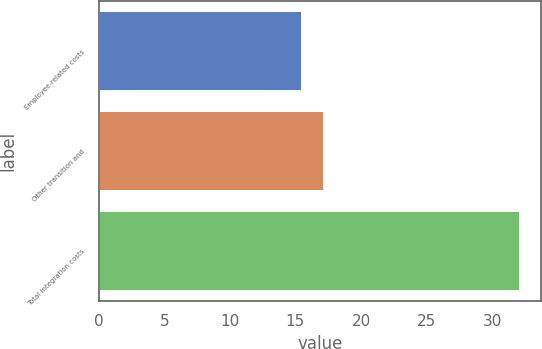Convert chart to OTSL. <chart><loc_0><loc_0><loc_500><loc_500><bar_chart><fcel>Employee-related costs<fcel>Other transition and<fcel>Total integration costs<nl><fcel>15.5<fcel>17.16<fcel>32.1<nl></chart> 